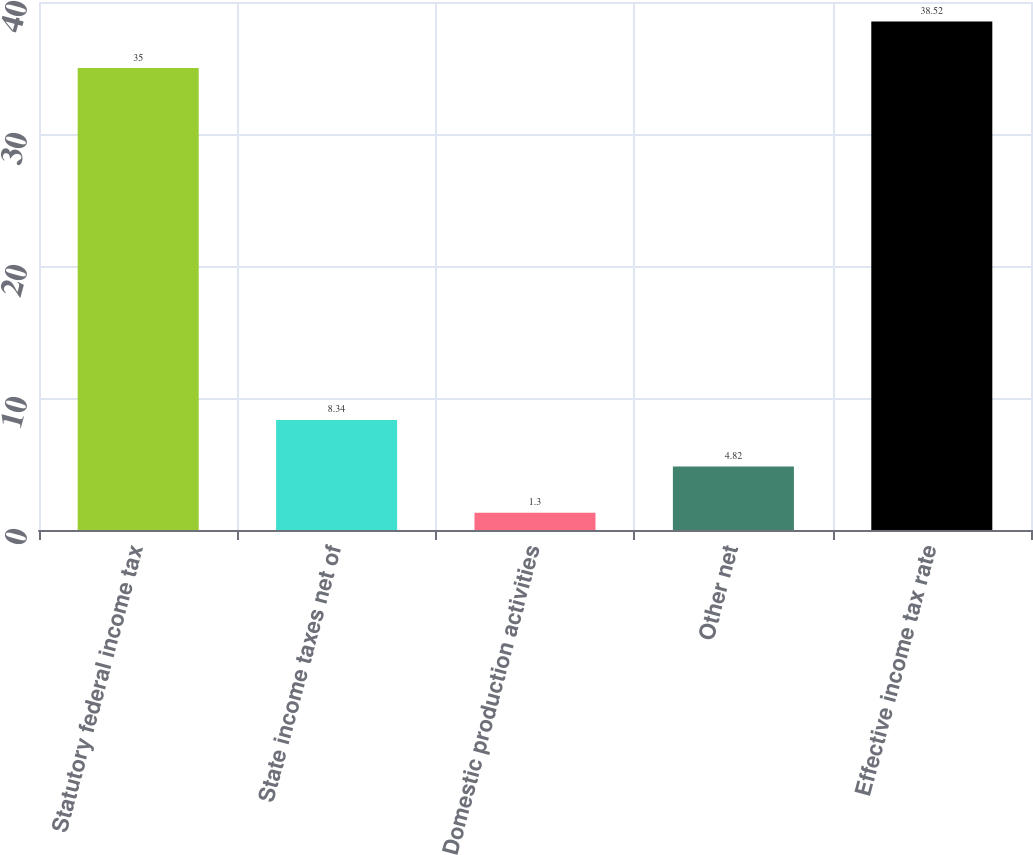Convert chart to OTSL. <chart><loc_0><loc_0><loc_500><loc_500><bar_chart><fcel>Statutory federal income tax<fcel>State income taxes net of<fcel>Domestic production activities<fcel>Other net<fcel>Effective income tax rate<nl><fcel>35<fcel>8.34<fcel>1.3<fcel>4.82<fcel>38.52<nl></chart> 